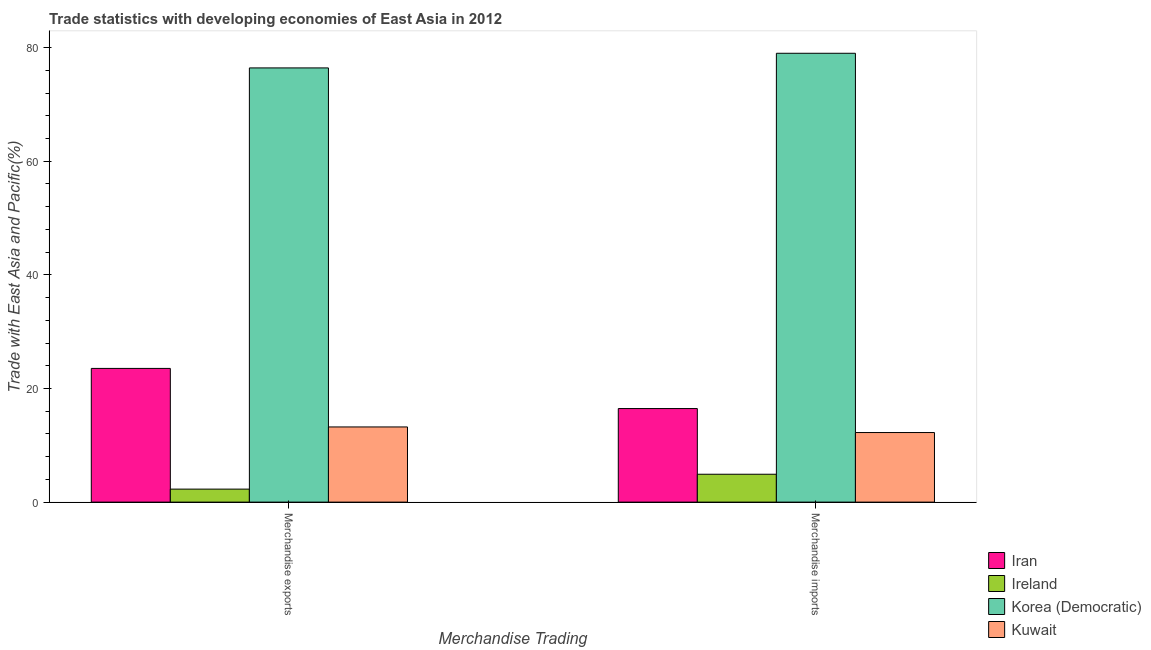How many different coloured bars are there?
Offer a terse response. 4. How many groups of bars are there?
Keep it short and to the point. 2. Are the number of bars per tick equal to the number of legend labels?
Provide a succinct answer. Yes. Are the number of bars on each tick of the X-axis equal?
Keep it short and to the point. Yes. How many bars are there on the 2nd tick from the left?
Ensure brevity in your answer.  4. How many bars are there on the 2nd tick from the right?
Your response must be concise. 4. What is the label of the 2nd group of bars from the left?
Offer a terse response. Merchandise imports. What is the merchandise exports in Korea (Democratic)?
Provide a short and direct response. 76.43. Across all countries, what is the maximum merchandise imports?
Your answer should be compact. 79. Across all countries, what is the minimum merchandise exports?
Make the answer very short. 2.29. In which country was the merchandise exports maximum?
Your response must be concise. Korea (Democratic). In which country was the merchandise imports minimum?
Provide a succinct answer. Ireland. What is the total merchandise imports in the graph?
Offer a terse response. 112.63. What is the difference between the merchandise exports in Ireland and that in Kuwait?
Ensure brevity in your answer.  -10.94. What is the difference between the merchandise imports in Iran and the merchandise exports in Kuwait?
Provide a succinct answer. 3.24. What is the average merchandise exports per country?
Provide a short and direct response. 28.87. What is the difference between the merchandise exports and merchandise imports in Korea (Democratic)?
Your answer should be very brief. -2.58. What is the ratio of the merchandise exports in Korea (Democratic) to that in Ireland?
Make the answer very short. 33.39. Is the merchandise exports in Korea (Democratic) less than that in Iran?
Provide a short and direct response. No. In how many countries, is the merchandise exports greater than the average merchandise exports taken over all countries?
Give a very brief answer. 1. What does the 3rd bar from the left in Merchandise imports represents?
Offer a very short reply. Korea (Democratic). What does the 3rd bar from the right in Merchandise exports represents?
Ensure brevity in your answer.  Ireland. Are all the bars in the graph horizontal?
Your response must be concise. No. How many countries are there in the graph?
Provide a succinct answer. 4. What is the difference between two consecutive major ticks on the Y-axis?
Provide a succinct answer. 20. Are the values on the major ticks of Y-axis written in scientific E-notation?
Make the answer very short. No. Does the graph contain grids?
Offer a very short reply. No. How many legend labels are there?
Keep it short and to the point. 4. What is the title of the graph?
Offer a very short reply. Trade statistics with developing economies of East Asia in 2012. What is the label or title of the X-axis?
Keep it short and to the point. Merchandise Trading. What is the label or title of the Y-axis?
Provide a succinct answer. Trade with East Asia and Pacific(%). What is the Trade with East Asia and Pacific(%) of Iran in Merchandise exports?
Keep it short and to the point. 23.53. What is the Trade with East Asia and Pacific(%) in Ireland in Merchandise exports?
Offer a terse response. 2.29. What is the Trade with East Asia and Pacific(%) in Korea (Democratic) in Merchandise exports?
Ensure brevity in your answer.  76.43. What is the Trade with East Asia and Pacific(%) of Kuwait in Merchandise exports?
Offer a terse response. 13.23. What is the Trade with East Asia and Pacific(%) in Iran in Merchandise imports?
Ensure brevity in your answer.  16.47. What is the Trade with East Asia and Pacific(%) in Ireland in Merchandise imports?
Ensure brevity in your answer.  4.91. What is the Trade with East Asia and Pacific(%) in Korea (Democratic) in Merchandise imports?
Give a very brief answer. 79. What is the Trade with East Asia and Pacific(%) in Kuwait in Merchandise imports?
Give a very brief answer. 12.25. Across all Merchandise Trading, what is the maximum Trade with East Asia and Pacific(%) of Iran?
Offer a very short reply. 23.53. Across all Merchandise Trading, what is the maximum Trade with East Asia and Pacific(%) in Ireland?
Your answer should be compact. 4.91. Across all Merchandise Trading, what is the maximum Trade with East Asia and Pacific(%) in Korea (Democratic)?
Your answer should be very brief. 79. Across all Merchandise Trading, what is the maximum Trade with East Asia and Pacific(%) in Kuwait?
Give a very brief answer. 13.23. Across all Merchandise Trading, what is the minimum Trade with East Asia and Pacific(%) of Iran?
Your response must be concise. 16.47. Across all Merchandise Trading, what is the minimum Trade with East Asia and Pacific(%) of Ireland?
Ensure brevity in your answer.  2.29. Across all Merchandise Trading, what is the minimum Trade with East Asia and Pacific(%) in Korea (Democratic)?
Keep it short and to the point. 76.43. Across all Merchandise Trading, what is the minimum Trade with East Asia and Pacific(%) in Kuwait?
Ensure brevity in your answer.  12.25. What is the total Trade with East Asia and Pacific(%) of Iran in the graph?
Offer a terse response. 40. What is the total Trade with East Asia and Pacific(%) of Ireland in the graph?
Your answer should be compact. 7.2. What is the total Trade with East Asia and Pacific(%) of Korea (Democratic) in the graph?
Offer a very short reply. 155.43. What is the total Trade with East Asia and Pacific(%) in Kuwait in the graph?
Your answer should be compact. 25.48. What is the difference between the Trade with East Asia and Pacific(%) in Iran in Merchandise exports and that in Merchandise imports?
Your answer should be very brief. 7.07. What is the difference between the Trade with East Asia and Pacific(%) in Ireland in Merchandise exports and that in Merchandise imports?
Ensure brevity in your answer.  -2.62. What is the difference between the Trade with East Asia and Pacific(%) in Korea (Democratic) in Merchandise exports and that in Merchandise imports?
Offer a very short reply. -2.58. What is the difference between the Trade with East Asia and Pacific(%) of Kuwait in Merchandise exports and that in Merchandise imports?
Provide a succinct answer. 0.98. What is the difference between the Trade with East Asia and Pacific(%) of Iran in Merchandise exports and the Trade with East Asia and Pacific(%) of Ireland in Merchandise imports?
Make the answer very short. 18.63. What is the difference between the Trade with East Asia and Pacific(%) of Iran in Merchandise exports and the Trade with East Asia and Pacific(%) of Korea (Democratic) in Merchandise imports?
Offer a terse response. -55.47. What is the difference between the Trade with East Asia and Pacific(%) in Iran in Merchandise exports and the Trade with East Asia and Pacific(%) in Kuwait in Merchandise imports?
Ensure brevity in your answer.  11.29. What is the difference between the Trade with East Asia and Pacific(%) in Ireland in Merchandise exports and the Trade with East Asia and Pacific(%) in Korea (Democratic) in Merchandise imports?
Keep it short and to the point. -76.71. What is the difference between the Trade with East Asia and Pacific(%) of Ireland in Merchandise exports and the Trade with East Asia and Pacific(%) of Kuwait in Merchandise imports?
Your answer should be very brief. -9.96. What is the difference between the Trade with East Asia and Pacific(%) in Korea (Democratic) in Merchandise exports and the Trade with East Asia and Pacific(%) in Kuwait in Merchandise imports?
Offer a terse response. 64.18. What is the average Trade with East Asia and Pacific(%) in Iran per Merchandise Trading?
Your response must be concise. 20. What is the average Trade with East Asia and Pacific(%) in Ireland per Merchandise Trading?
Offer a very short reply. 3.6. What is the average Trade with East Asia and Pacific(%) of Korea (Democratic) per Merchandise Trading?
Ensure brevity in your answer.  77.72. What is the average Trade with East Asia and Pacific(%) of Kuwait per Merchandise Trading?
Keep it short and to the point. 12.74. What is the difference between the Trade with East Asia and Pacific(%) of Iran and Trade with East Asia and Pacific(%) of Ireland in Merchandise exports?
Provide a short and direct response. 21.25. What is the difference between the Trade with East Asia and Pacific(%) of Iran and Trade with East Asia and Pacific(%) of Korea (Democratic) in Merchandise exports?
Ensure brevity in your answer.  -52.89. What is the difference between the Trade with East Asia and Pacific(%) of Iran and Trade with East Asia and Pacific(%) of Kuwait in Merchandise exports?
Ensure brevity in your answer.  10.3. What is the difference between the Trade with East Asia and Pacific(%) of Ireland and Trade with East Asia and Pacific(%) of Korea (Democratic) in Merchandise exports?
Make the answer very short. -74.14. What is the difference between the Trade with East Asia and Pacific(%) in Ireland and Trade with East Asia and Pacific(%) in Kuwait in Merchandise exports?
Your answer should be very brief. -10.94. What is the difference between the Trade with East Asia and Pacific(%) of Korea (Democratic) and Trade with East Asia and Pacific(%) of Kuwait in Merchandise exports?
Offer a very short reply. 63.19. What is the difference between the Trade with East Asia and Pacific(%) in Iran and Trade with East Asia and Pacific(%) in Ireland in Merchandise imports?
Offer a very short reply. 11.56. What is the difference between the Trade with East Asia and Pacific(%) in Iran and Trade with East Asia and Pacific(%) in Korea (Democratic) in Merchandise imports?
Your response must be concise. -62.54. What is the difference between the Trade with East Asia and Pacific(%) of Iran and Trade with East Asia and Pacific(%) of Kuwait in Merchandise imports?
Your answer should be compact. 4.22. What is the difference between the Trade with East Asia and Pacific(%) in Ireland and Trade with East Asia and Pacific(%) in Korea (Democratic) in Merchandise imports?
Provide a short and direct response. -74.1. What is the difference between the Trade with East Asia and Pacific(%) in Ireland and Trade with East Asia and Pacific(%) in Kuwait in Merchandise imports?
Your answer should be very brief. -7.34. What is the difference between the Trade with East Asia and Pacific(%) in Korea (Democratic) and Trade with East Asia and Pacific(%) in Kuwait in Merchandise imports?
Offer a very short reply. 66.76. What is the ratio of the Trade with East Asia and Pacific(%) of Iran in Merchandise exports to that in Merchandise imports?
Your response must be concise. 1.43. What is the ratio of the Trade with East Asia and Pacific(%) of Ireland in Merchandise exports to that in Merchandise imports?
Provide a short and direct response. 0.47. What is the ratio of the Trade with East Asia and Pacific(%) in Korea (Democratic) in Merchandise exports to that in Merchandise imports?
Offer a terse response. 0.97. What is the ratio of the Trade with East Asia and Pacific(%) of Kuwait in Merchandise exports to that in Merchandise imports?
Offer a very short reply. 1.08. What is the difference between the highest and the second highest Trade with East Asia and Pacific(%) of Iran?
Your response must be concise. 7.07. What is the difference between the highest and the second highest Trade with East Asia and Pacific(%) of Ireland?
Ensure brevity in your answer.  2.62. What is the difference between the highest and the second highest Trade with East Asia and Pacific(%) of Korea (Democratic)?
Keep it short and to the point. 2.58. What is the difference between the highest and the second highest Trade with East Asia and Pacific(%) of Kuwait?
Your answer should be very brief. 0.98. What is the difference between the highest and the lowest Trade with East Asia and Pacific(%) in Iran?
Provide a short and direct response. 7.07. What is the difference between the highest and the lowest Trade with East Asia and Pacific(%) in Ireland?
Provide a short and direct response. 2.62. What is the difference between the highest and the lowest Trade with East Asia and Pacific(%) in Korea (Democratic)?
Offer a very short reply. 2.58. What is the difference between the highest and the lowest Trade with East Asia and Pacific(%) of Kuwait?
Ensure brevity in your answer.  0.98. 